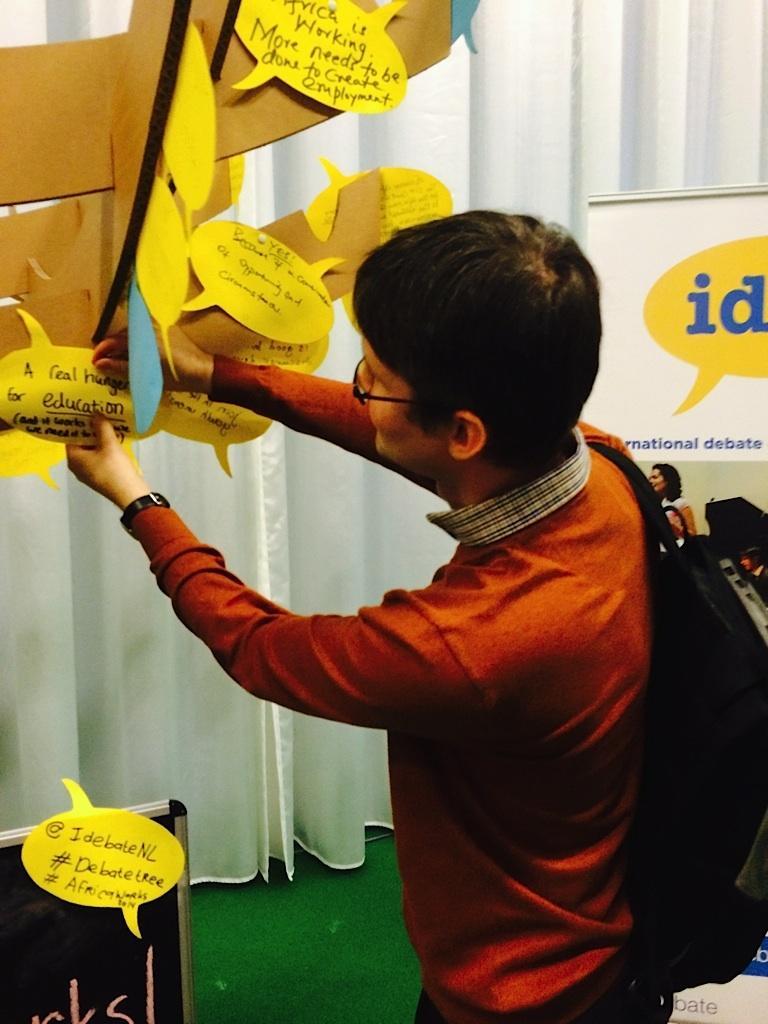How would you summarize this image in a sentence or two? In this image we can see a person wearing specs, watch and a bag. There is a board with papers. On the papers there is text. In the back there are curtains. 